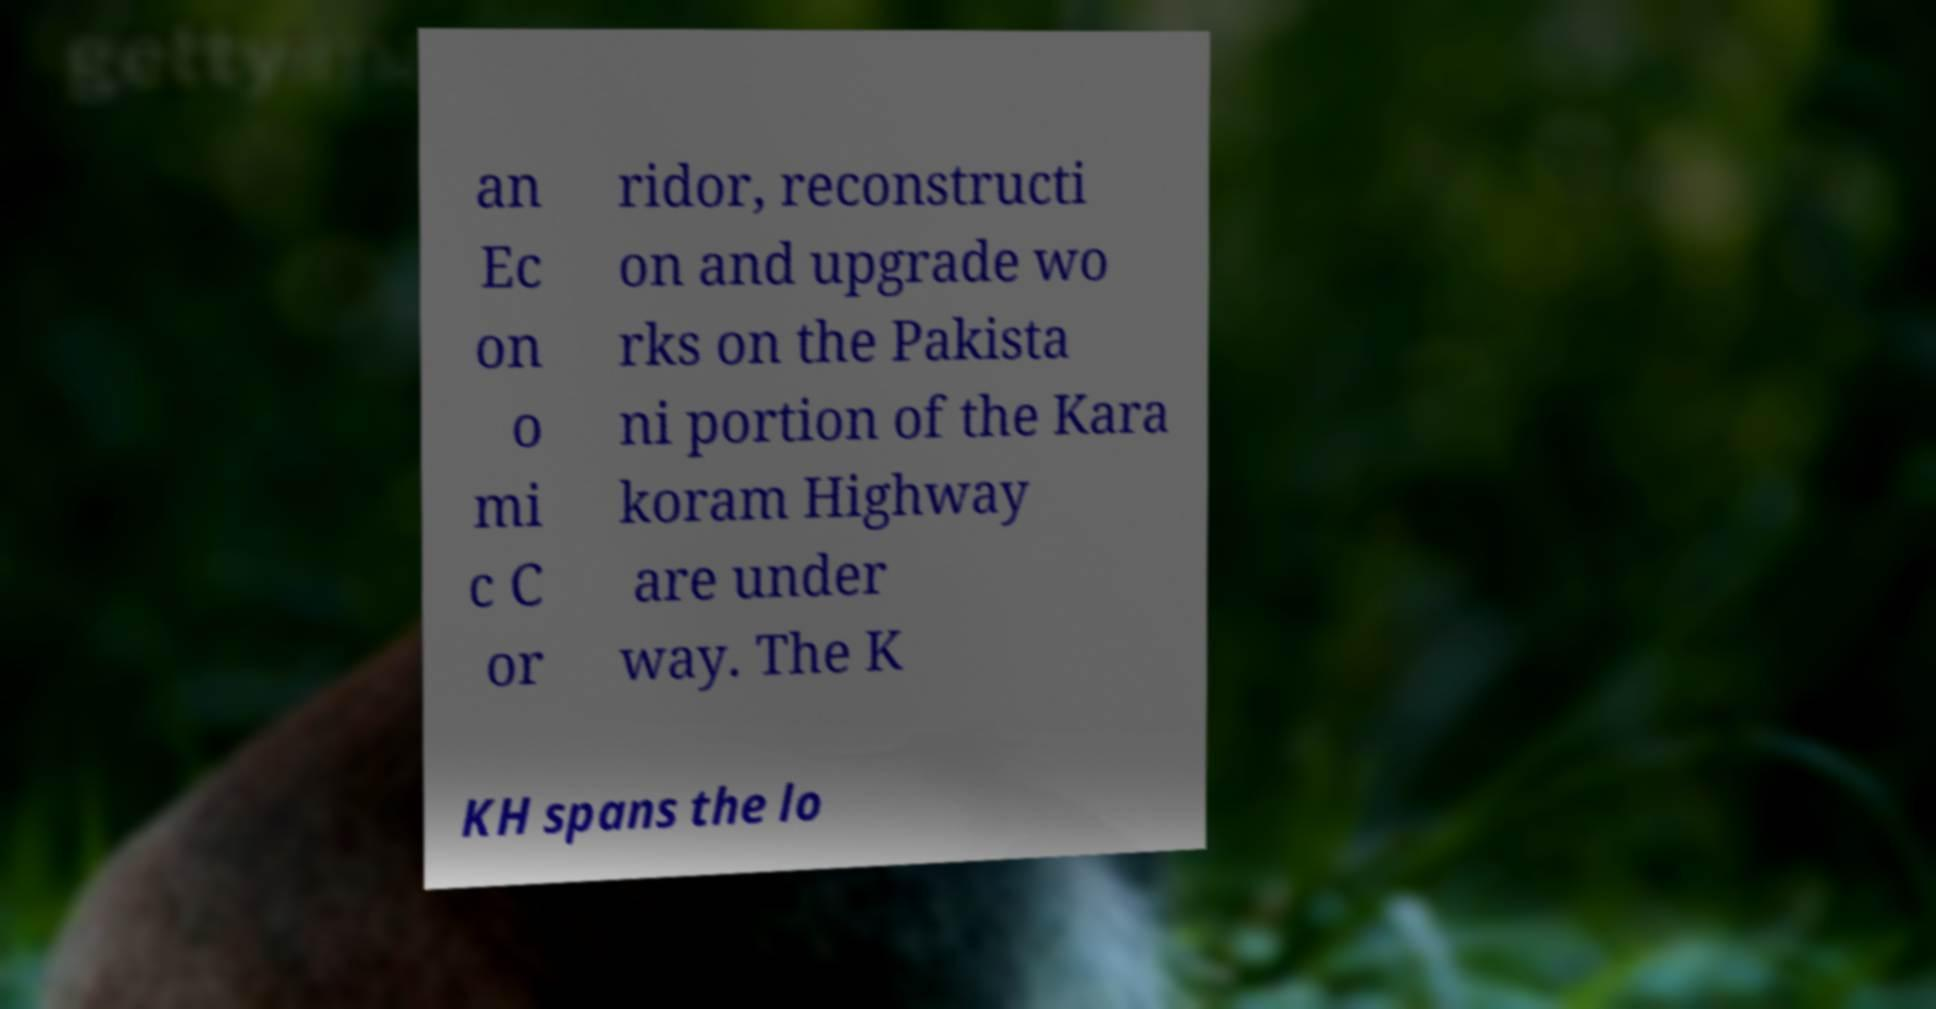I need the written content from this picture converted into text. Can you do that? an Ec on o mi c C or ridor, reconstructi on and upgrade wo rks on the Pakista ni portion of the Kara koram Highway are under way. The K KH spans the lo 